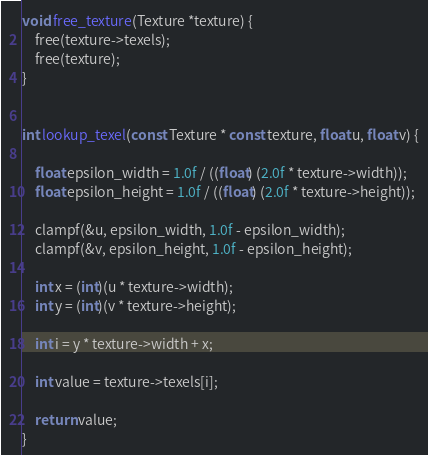Convert code to text. <code><loc_0><loc_0><loc_500><loc_500><_C_>

void free_texture(Texture *texture) {
    free(texture->texels);
    free(texture);
}


int lookup_texel(const Texture * const texture, float u, float v) {

    float epsilon_width = 1.0f / ((float) (2.0f * texture->width));
    float epsilon_height = 1.0f / ((float) (2.0f * texture->height));

    clampf(&u, epsilon_width, 1.0f - epsilon_width);
    clampf(&v, epsilon_height, 1.0f - epsilon_height);

    int x = (int)(u * texture->width);
    int y = (int)(v * texture->height);

    int i = y * texture->width + x;

    int value = texture->texels[i];

    return value;
}
</code> 